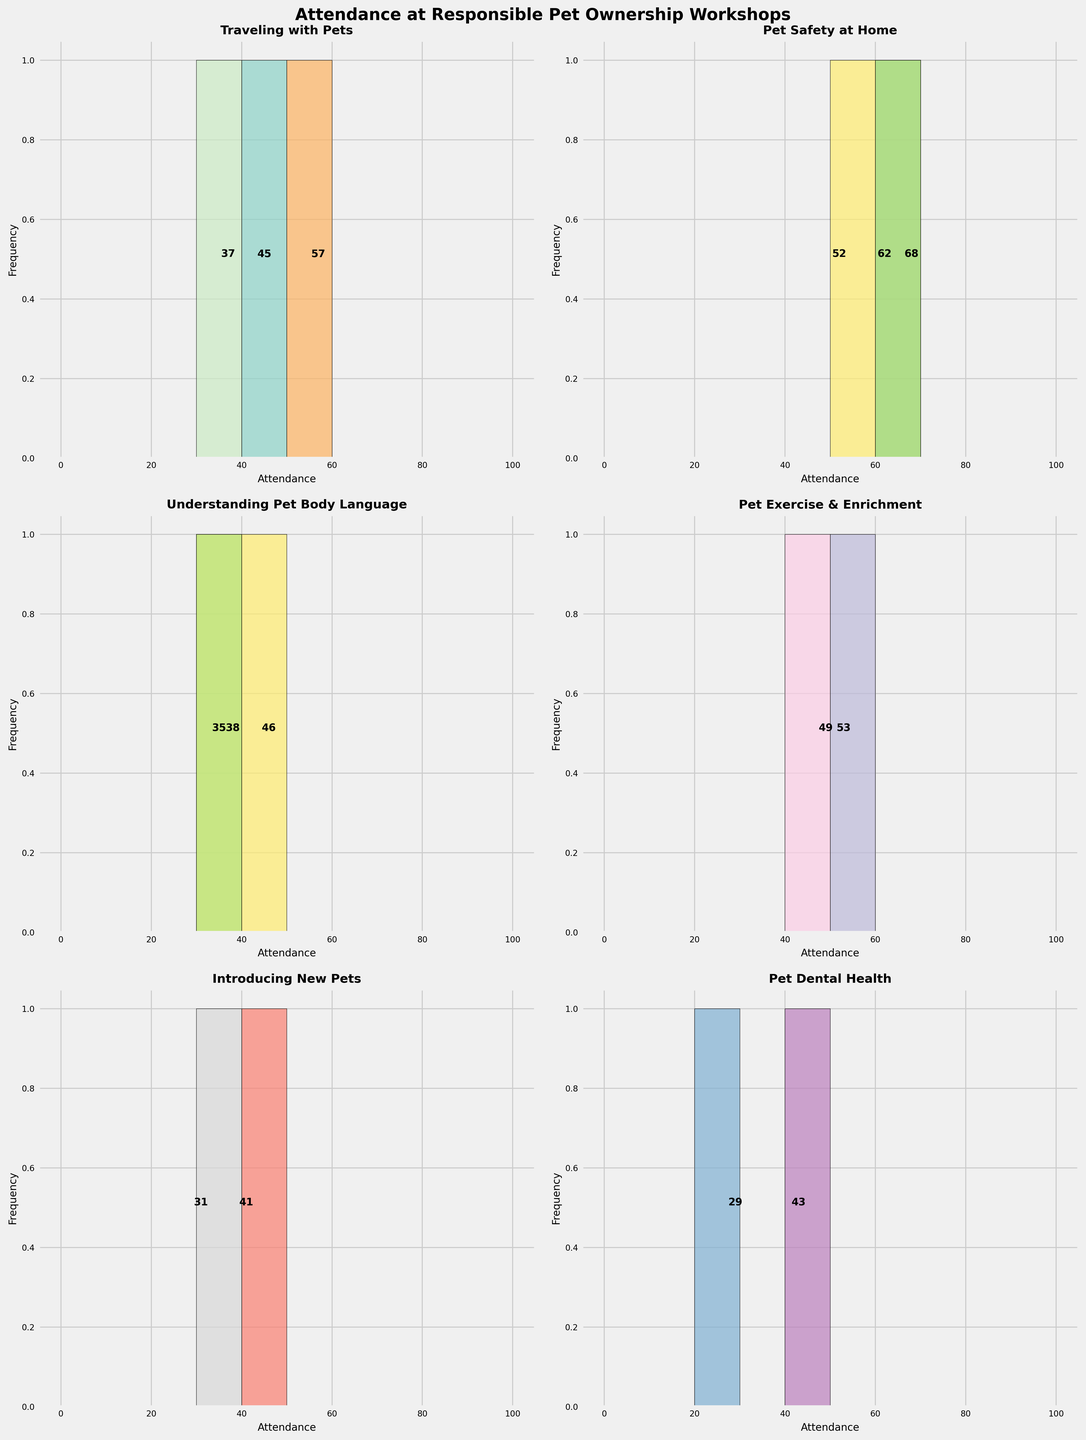What is the title of the figure? The title of the figure is clearly stated at the top.
Answer: Attendance at Responsible Pet Ownership Workshops What range of attendance is depicted on the x-axis? The x-axis of each subplot shows the range from 0 to 100.
Answer: 0 to 100 Which workshop topic has the highest attendance? The highest attendance is shown by the highest number (62) out of all the subplots. This corresponds to "Dog Training".
Answer: Dog Training Which workshop topic has the lowest attendance? The lowest attendance is identified as 29, which is shown in the subplot for "Small Animal Care".
Answer: Small Animal Care Is there any workshop topic with an attendance exactly equal to 50? By checking each subplot, none of the workshops have an attendance of exactly 50.
Answer: No How many workshop topics have attendance figures greater than 50? By observing each subplot, the workshop topics with attendance greater than 50 are "Dog Training," "Pet Nutrition," "Pet First Aid," and "Adopting Rescue Animals". This makes a total of 4 topics.
Answer: 4 Which workshop topic has an attendance closest to 40? "Grooming Essentials" has an attendance of 41, which is closest to 40 compared to other workshops.
Answer: Grooming Essentials What is the difference between the highest and the lowest attendance among the workshops? The highest attendance is 68 ("Adopting Rescue Animals") and the lowest is 29 ("Small Animal Care"). Difference is calculated as 68 - 29 = 39.
Answer: 39 Which workshop topic's attendance is most similar to "Basic Pet Care"? "Understanding Pet Body Language" has an attendance of 46, which is closest to "Basic Pet Care" with an attendance of 45.
Answer: Understanding Pet Body Language Are there more workshops with attendance above or below 45? By counting the number of workshops above and below 45, there are 8 workshops with attendance above 45 and 7 workshops with attendance below 45. Hence, there are more workshops with attendance above 45.
Answer: Above 